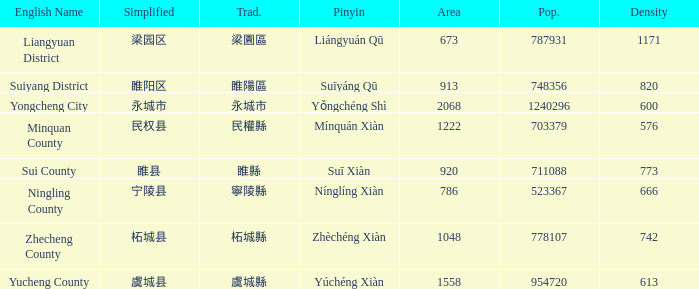What is the traditional with density of 820? 睢陽區. 